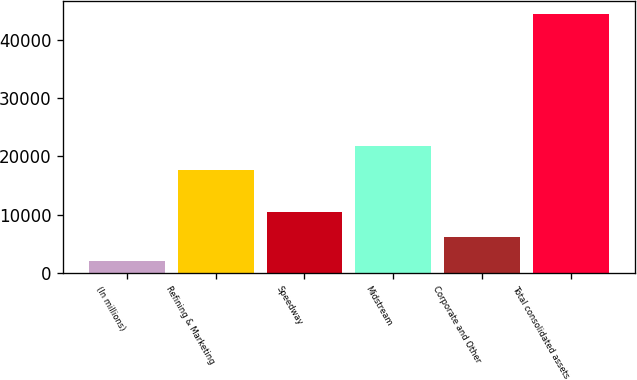<chart> <loc_0><loc_0><loc_500><loc_500><bar_chart><fcel>(In millions)<fcel>Refining & Marketing<fcel>Speedway<fcel>Midstream<fcel>Corporate and Other<fcel>Total consolidated assets<nl><fcel>2016<fcel>17601<fcel>10495.4<fcel>21840.7<fcel>6255.7<fcel>44413<nl></chart> 